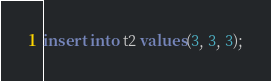<code> <loc_0><loc_0><loc_500><loc_500><_SQL_>insert into t2 values(3, 3, 3);
</code> 